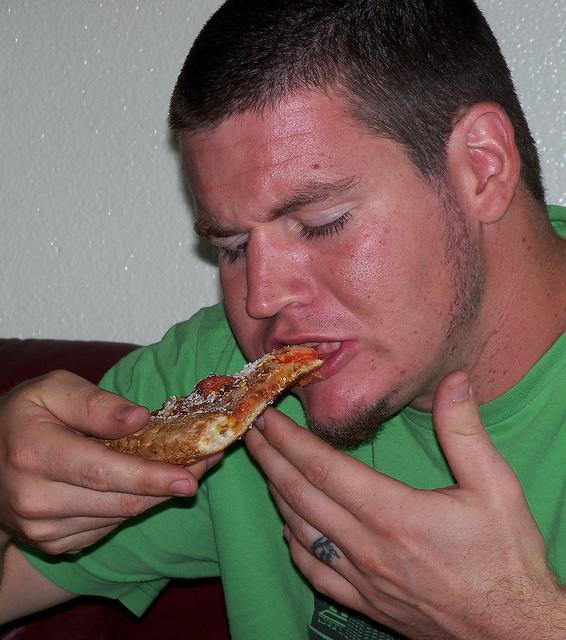Does the image validate the caption "The pizza is with the person."?
Answer yes or no. Yes. 